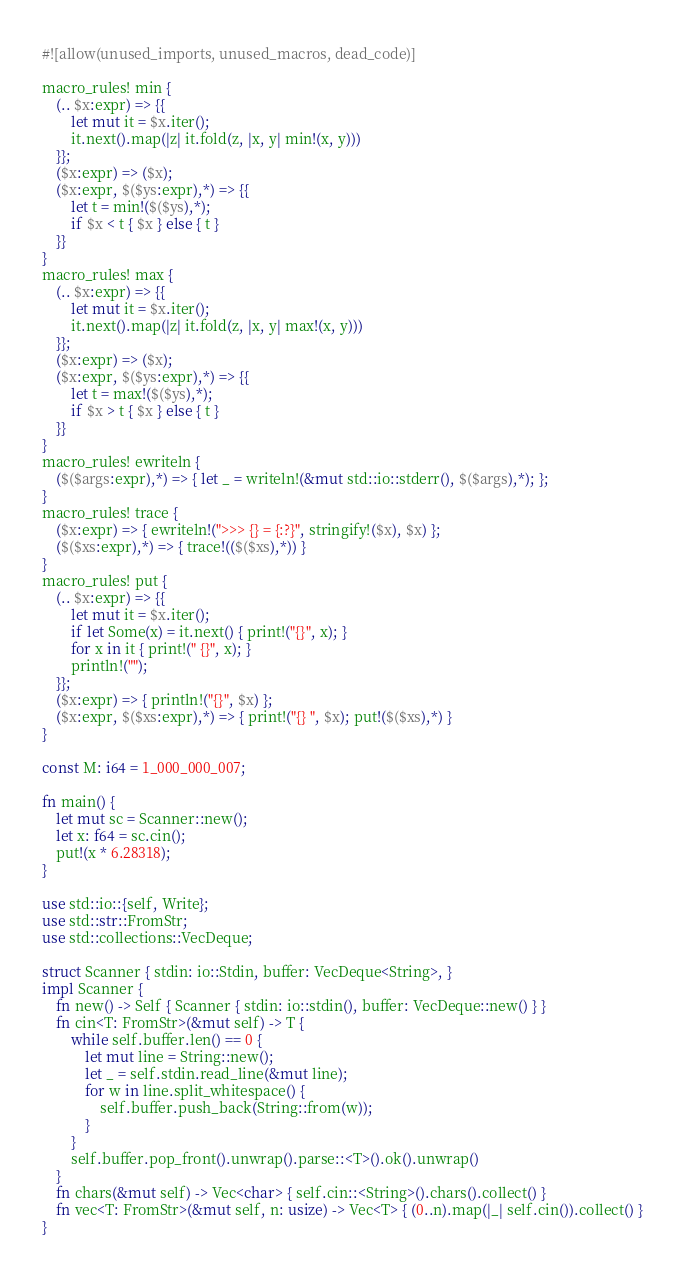Convert code to text. <code><loc_0><loc_0><loc_500><loc_500><_Rust_>#![allow(unused_imports, unused_macros, dead_code)]

macro_rules! min {
    (.. $x:expr) => {{
        let mut it = $x.iter();
        it.next().map(|z| it.fold(z, |x, y| min!(x, y)))
    }};
    ($x:expr) => ($x);
    ($x:expr, $($ys:expr),*) => {{
        let t = min!($($ys),*);
        if $x < t { $x } else { t }
    }}
}
macro_rules! max {
    (.. $x:expr) => {{
        let mut it = $x.iter();
        it.next().map(|z| it.fold(z, |x, y| max!(x, y)))
    }};
    ($x:expr) => ($x);
    ($x:expr, $($ys:expr),*) => {{
        let t = max!($($ys),*);
        if $x > t { $x } else { t }
    }}
}
macro_rules! ewriteln {
    ($($args:expr),*) => { let _ = writeln!(&mut std::io::stderr(), $($args),*); };
}
macro_rules! trace {
    ($x:expr) => { ewriteln!(">>> {} = {:?}", stringify!($x), $x) };
    ($($xs:expr),*) => { trace!(($($xs),*)) }
}
macro_rules! put {
    (.. $x:expr) => {{
        let mut it = $x.iter();
        if let Some(x) = it.next() { print!("{}", x); }
        for x in it { print!(" {}", x); }
        println!("");
    }};
    ($x:expr) => { println!("{}", $x) };
    ($x:expr, $($xs:expr),*) => { print!("{} ", $x); put!($($xs),*) }
}

const M: i64 = 1_000_000_007;

fn main() {
    let mut sc = Scanner::new();
    let x: f64 = sc.cin();
    put!(x * 6.28318);
}

use std::io::{self, Write};
use std::str::FromStr;
use std::collections::VecDeque;

struct Scanner { stdin: io::Stdin, buffer: VecDeque<String>, }
impl Scanner {
    fn new() -> Self { Scanner { stdin: io::stdin(), buffer: VecDeque::new() } }
    fn cin<T: FromStr>(&mut self) -> T {
        while self.buffer.len() == 0 {
            let mut line = String::new();
            let _ = self.stdin.read_line(&mut line);
            for w in line.split_whitespace() {
                self.buffer.push_back(String::from(w));
            }
        }
        self.buffer.pop_front().unwrap().parse::<T>().ok().unwrap()
    }
    fn chars(&mut self) -> Vec<char> { self.cin::<String>().chars().collect() }
    fn vec<T: FromStr>(&mut self, n: usize) -> Vec<T> { (0..n).map(|_| self.cin()).collect() }
}
</code> 